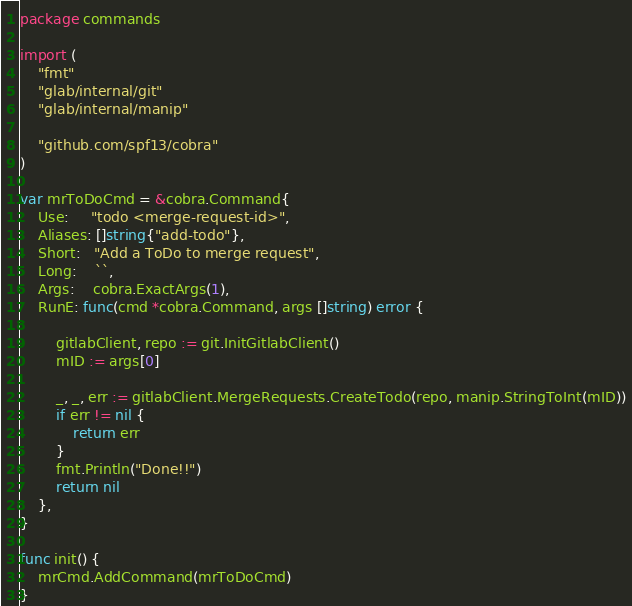Convert code to text. <code><loc_0><loc_0><loc_500><loc_500><_Go_>package commands

import (
	"fmt"
	"glab/internal/git"
	"glab/internal/manip"

	"github.com/spf13/cobra"
)

var mrToDoCmd = &cobra.Command{
	Use:     "todo <merge-request-id>",
	Aliases: []string{"add-todo"},
	Short:   "Add a ToDo to merge request",
	Long:    ``,
	Args:    cobra.ExactArgs(1),
	RunE: func(cmd *cobra.Command, args []string) error {

		gitlabClient, repo := git.InitGitlabClient()
		mID := args[0]

		_, _, err := gitlabClient.MergeRequests.CreateTodo(repo, manip.StringToInt(mID))
		if err != nil {
			return err
		}
		fmt.Println("Done!!")
		return nil
	},
}

func init() {
	mrCmd.AddCommand(mrToDoCmd)
}
</code> 